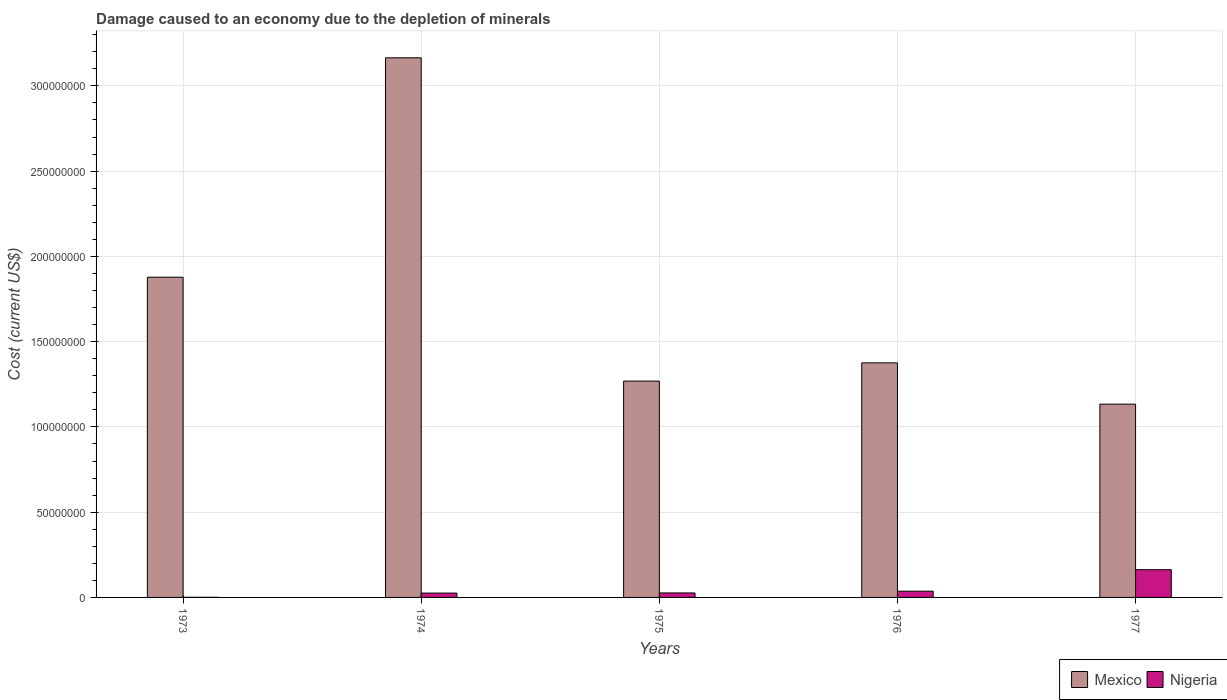How many different coloured bars are there?
Offer a very short reply. 2. How many groups of bars are there?
Your answer should be very brief. 5. Are the number of bars on each tick of the X-axis equal?
Ensure brevity in your answer.  Yes. How many bars are there on the 2nd tick from the right?
Your answer should be compact. 2. What is the label of the 1st group of bars from the left?
Your response must be concise. 1973. What is the cost of damage caused due to the depletion of minerals in Nigeria in 1977?
Keep it short and to the point. 1.63e+07. Across all years, what is the maximum cost of damage caused due to the depletion of minerals in Mexico?
Give a very brief answer. 3.16e+08. Across all years, what is the minimum cost of damage caused due to the depletion of minerals in Mexico?
Provide a short and direct response. 1.13e+08. In which year was the cost of damage caused due to the depletion of minerals in Mexico maximum?
Provide a short and direct response. 1974. In which year was the cost of damage caused due to the depletion of minerals in Mexico minimum?
Provide a short and direct response. 1977. What is the total cost of damage caused due to the depletion of minerals in Mexico in the graph?
Your response must be concise. 8.82e+08. What is the difference between the cost of damage caused due to the depletion of minerals in Mexico in 1973 and that in 1977?
Give a very brief answer. 7.44e+07. What is the difference between the cost of damage caused due to the depletion of minerals in Mexico in 1975 and the cost of damage caused due to the depletion of minerals in Nigeria in 1974?
Provide a succinct answer. 1.24e+08. What is the average cost of damage caused due to the depletion of minerals in Nigeria per year?
Provide a succinct answer. 5.03e+06. In the year 1976, what is the difference between the cost of damage caused due to the depletion of minerals in Nigeria and cost of damage caused due to the depletion of minerals in Mexico?
Give a very brief answer. -1.34e+08. In how many years, is the cost of damage caused due to the depletion of minerals in Mexico greater than 140000000 US$?
Your response must be concise. 2. What is the ratio of the cost of damage caused due to the depletion of minerals in Nigeria in 1975 to that in 1977?
Offer a very short reply. 0.16. Is the cost of damage caused due to the depletion of minerals in Nigeria in 1973 less than that in 1974?
Keep it short and to the point. Yes. What is the difference between the highest and the second highest cost of damage caused due to the depletion of minerals in Mexico?
Provide a succinct answer. 1.29e+08. What is the difference between the highest and the lowest cost of damage caused due to the depletion of minerals in Mexico?
Offer a very short reply. 2.03e+08. Is the sum of the cost of damage caused due to the depletion of minerals in Nigeria in 1973 and 1974 greater than the maximum cost of damage caused due to the depletion of minerals in Mexico across all years?
Make the answer very short. No. What does the 1st bar from the left in 1977 represents?
Your answer should be very brief. Mexico. How many bars are there?
Your answer should be very brief. 10. How many years are there in the graph?
Make the answer very short. 5. What is the difference between two consecutive major ticks on the Y-axis?
Provide a short and direct response. 5.00e+07. Are the values on the major ticks of Y-axis written in scientific E-notation?
Offer a very short reply. No. How many legend labels are there?
Make the answer very short. 2. What is the title of the graph?
Keep it short and to the point. Damage caused to an economy due to the depletion of minerals. What is the label or title of the X-axis?
Keep it short and to the point. Years. What is the label or title of the Y-axis?
Your answer should be compact. Cost (current US$). What is the Cost (current US$) in Mexico in 1973?
Offer a very short reply. 1.88e+08. What is the Cost (current US$) in Nigeria in 1973?
Provide a succinct answer. 6.24e+04. What is the Cost (current US$) of Mexico in 1974?
Make the answer very short. 3.16e+08. What is the Cost (current US$) of Nigeria in 1974?
Keep it short and to the point. 2.55e+06. What is the Cost (current US$) of Mexico in 1975?
Your answer should be very brief. 1.27e+08. What is the Cost (current US$) of Nigeria in 1975?
Ensure brevity in your answer.  2.63e+06. What is the Cost (current US$) of Mexico in 1976?
Make the answer very short. 1.38e+08. What is the Cost (current US$) of Nigeria in 1976?
Ensure brevity in your answer.  3.65e+06. What is the Cost (current US$) in Mexico in 1977?
Make the answer very short. 1.13e+08. What is the Cost (current US$) of Nigeria in 1977?
Ensure brevity in your answer.  1.63e+07. Across all years, what is the maximum Cost (current US$) in Mexico?
Ensure brevity in your answer.  3.16e+08. Across all years, what is the maximum Cost (current US$) in Nigeria?
Your answer should be compact. 1.63e+07. Across all years, what is the minimum Cost (current US$) in Mexico?
Give a very brief answer. 1.13e+08. Across all years, what is the minimum Cost (current US$) of Nigeria?
Give a very brief answer. 6.24e+04. What is the total Cost (current US$) in Mexico in the graph?
Offer a terse response. 8.82e+08. What is the total Cost (current US$) of Nigeria in the graph?
Your response must be concise. 2.52e+07. What is the difference between the Cost (current US$) in Mexico in 1973 and that in 1974?
Ensure brevity in your answer.  -1.29e+08. What is the difference between the Cost (current US$) in Nigeria in 1973 and that in 1974?
Give a very brief answer. -2.49e+06. What is the difference between the Cost (current US$) of Mexico in 1973 and that in 1975?
Keep it short and to the point. 6.09e+07. What is the difference between the Cost (current US$) of Nigeria in 1973 and that in 1975?
Give a very brief answer. -2.57e+06. What is the difference between the Cost (current US$) of Mexico in 1973 and that in 1976?
Give a very brief answer. 5.02e+07. What is the difference between the Cost (current US$) of Nigeria in 1973 and that in 1976?
Your response must be concise. -3.59e+06. What is the difference between the Cost (current US$) in Mexico in 1973 and that in 1977?
Provide a succinct answer. 7.44e+07. What is the difference between the Cost (current US$) in Nigeria in 1973 and that in 1977?
Provide a short and direct response. -1.62e+07. What is the difference between the Cost (current US$) of Mexico in 1974 and that in 1975?
Provide a short and direct response. 1.90e+08. What is the difference between the Cost (current US$) in Nigeria in 1974 and that in 1975?
Offer a very short reply. -8.23e+04. What is the difference between the Cost (current US$) in Mexico in 1974 and that in 1976?
Offer a terse response. 1.79e+08. What is the difference between the Cost (current US$) of Nigeria in 1974 and that in 1976?
Keep it short and to the point. -1.10e+06. What is the difference between the Cost (current US$) of Mexico in 1974 and that in 1977?
Your answer should be compact. 2.03e+08. What is the difference between the Cost (current US$) of Nigeria in 1974 and that in 1977?
Your response must be concise. -1.37e+07. What is the difference between the Cost (current US$) of Mexico in 1975 and that in 1976?
Ensure brevity in your answer.  -1.07e+07. What is the difference between the Cost (current US$) in Nigeria in 1975 and that in 1976?
Keep it short and to the point. -1.02e+06. What is the difference between the Cost (current US$) in Mexico in 1975 and that in 1977?
Your answer should be very brief. 1.35e+07. What is the difference between the Cost (current US$) of Nigeria in 1975 and that in 1977?
Your answer should be compact. -1.36e+07. What is the difference between the Cost (current US$) of Mexico in 1976 and that in 1977?
Provide a short and direct response. 2.42e+07. What is the difference between the Cost (current US$) in Nigeria in 1976 and that in 1977?
Offer a very short reply. -1.26e+07. What is the difference between the Cost (current US$) in Mexico in 1973 and the Cost (current US$) in Nigeria in 1974?
Your response must be concise. 1.85e+08. What is the difference between the Cost (current US$) in Mexico in 1973 and the Cost (current US$) in Nigeria in 1975?
Offer a terse response. 1.85e+08. What is the difference between the Cost (current US$) of Mexico in 1973 and the Cost (current US$) of Nigeria in 1976?
Give a very brief answer. 1.84e+08. What is the difference between the Cost (current US$) in Mexico in 1973 and the Cost (current US$) in Nigeria in 1977?
Keep it short and to the point. 1.72e+08. What is the difference between the Cost (current US$) in Mexico in 1974 and the Cost (current US$) in Nigeria in 1975?
Provide a short and direct response. 3.14e+08. What is the difference between the Cost (current US$) of Mexico in 1974 and the Cost (current US$) of Nigeria in 1976?
Keep it short and to the point. 3.13e+08. What is the difference between the Cost (current US$) in Mexico in 1974 and the Cost (current US$) in Nigeria in 1977?
Provide a short and direct response. 3.00e+08. What is the difference between the Cost (current US$) of Mexico in 1975 and the Cost (current US$) of Nigeria in 1976?
Offer a very short reply. 1.23e+08. What is the difference between the Cost (current US$) of Mexico in 1975 and the Cost (current US$) of Nigeria in 1977?
Your answer should be very brief. 1.11e+08. What is the difference between the Cost (current US$) of Mexico in 1976 and the Cost (current US$) of Nigeria in 1977?
Give a very brief answer. 1.21e+08. What is the average Cost (current US$) in Mexico per year?
Provide a succinct answer. 1.76e+08. What is the average Cost (current US$) of Nigeria per year?
Offer a very short reply. 5.03e+06. In the year 1973, what is the difference between the Cost (current US$) of Mexico and Cost (current US$) of Nigeria?
Provide a succinct answer. 1.88e+08. In the year 1974, what is the difference between the Cost (current US$) of Mexico and Cost (current US$) of Nigeria?
Your response must be concise. 3.14e+08. In the year 1975, what is the difference between the Cost (current US$) of Mexico and Cost (current US$) of Nigeria?
Ensure brevity in your answer.  1.24e+08. In the year 1976, what is the difference between the Cost (current US$) of Mexico and Cost (current US$) of Nigeria?
Keep it short and to the point. 1.34e+08. In the year 1977, what is the difference between the Cost (current US$) in Mexico and Cost (current US$) in Nigeria?
Your response must be concise. 9.71e+07. What is the ratio of the Cost (current US$) in Mexico in 1973 to that in 1974?
Provide a short and direct response. 0.59. What is the ratio of the Cost (current US$) in Nigeria in 1973 to that in 1974?
Provide a succinct answer. 0.02. What is the ratio of the Cost (current US$) in Mexico in 1973 to that in 1975?
Offer a terse response. 1.48. What is the ratio of the Cost (current US$) in Nigeria in 1973 to that in 1975?
Ensure brevity in your answer.  0.02. What is the ratio of the Cost (current US$) in Mexico in 1973 to that in 1976?
Make the answer very short. 1.37. What is the ratio of the Cost (current US$) in Nigeria in 1973 to that in 1976?
Provide a succinct answer. 0.02. What is the ratio of the Cost (current US$) of Mexico in 1973 to that in 1977?
Your answer should be very brief. 1.66. What is the ratio of the Cost (current US$) of Nigeria in 1973 to that in 1977?
Keep it short and to the point. 0. What is the ratio of the Cost (current US$) of Mexico in 1974 to that in 1975?
Ensure brevity in your answer.  2.49. What is the ratio of the Cost (current US$) of Nigeria in 1974 to that in 1975?
Offer a very short reply. 0.97. What is the ratio of the Cost (current US$) of Mexico in 1974 to that in 1976?
Offer a very short reply. 2.3. What is the ratio of the Cost (current US$) of Nigeria in 1974 to that in 1976?
Offer a terse response. 0.7. What is the ratio of the Cost (current US$) in Mexico in 1974 to that in 1977?
Ensure brevity in your answer.  2.79. What is the ratio of the Cost (current US$) in Nigeria in 1974 to that in 1977?
Provide a short and direct response. 0.16. What is the ratio of the Cost (current US$) in Mexico in 1975 to that in 1976?
Your answer should be very brief. 0.92. What is the ratio of the Cost (current US$) of Nigeria in 1975 to that in 1976?
Provide a succinct answer. 0.72. What is the ratio of the Cost (current US$) of Mexico in 1975 to that in 1977?
Provide a short and direct response. 1.12. What is the ratio of the Cost (current US$) in Nigeria in 1975 to that in 1977?
Your response must be concise. 0.16. What is the ratio of the Cost (current US$) of Mexico in 1976 to that in 1977?
Your answer should be compact. 1.21. What is the ratio of the Cost (current US$) of Nigeria in 1976 to that in 1977?
Offer a terse response. 0.22. What is the difference between the highest and the second highest Cost (current US$) in Mexico?
Provide a succinct answer. 1.29e+08. What is the difference between the highest and the second highest Cost (current US$) of Nigeria?
Your answer should be very brief. 1.26e+07. What is the difference between the highest and the lowest Cost (current US$) in Mexico?
Provide a succinct answer. 2.03e+08. What is the difference between the highest and the lowest Cost (current US$) in Nigeria?
Give a very brief answer. 1.62e+07. 